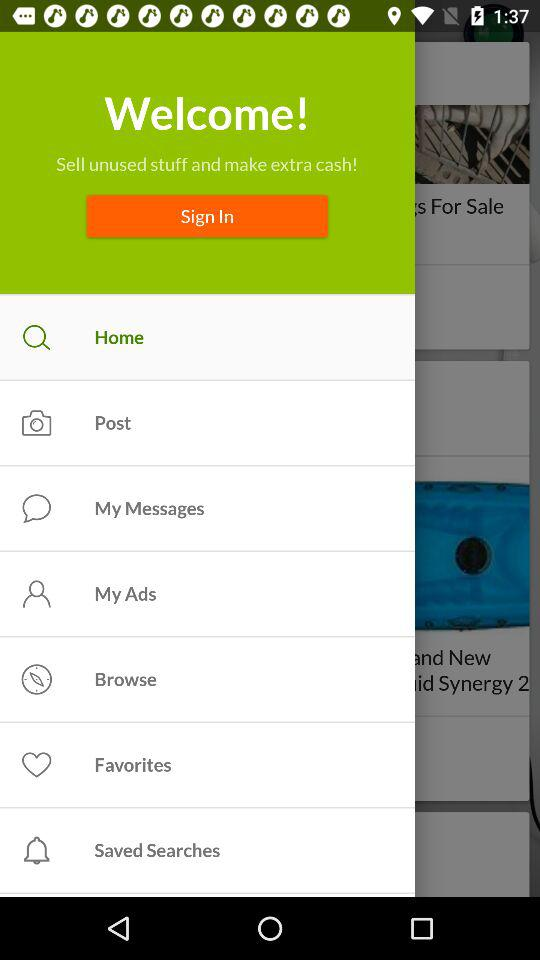How many notifications are there in "Favorites"?
When the provided information is insufficient, respond with <no answer>. <no answer> 